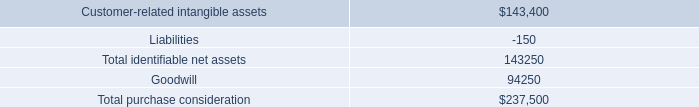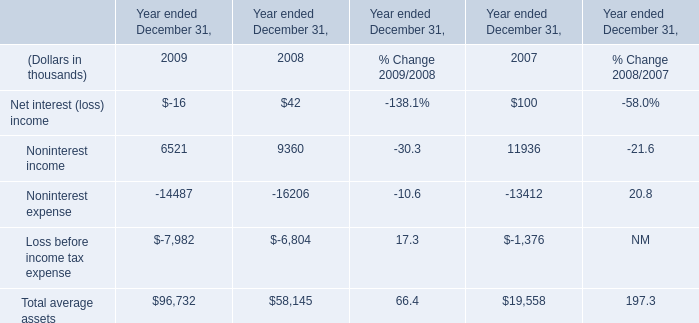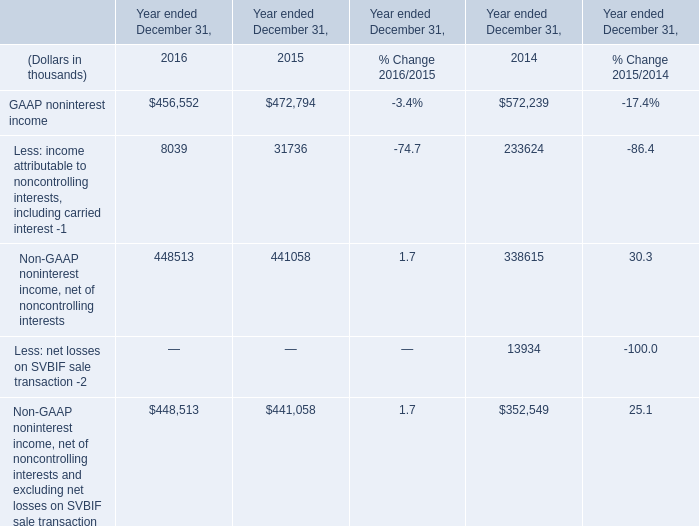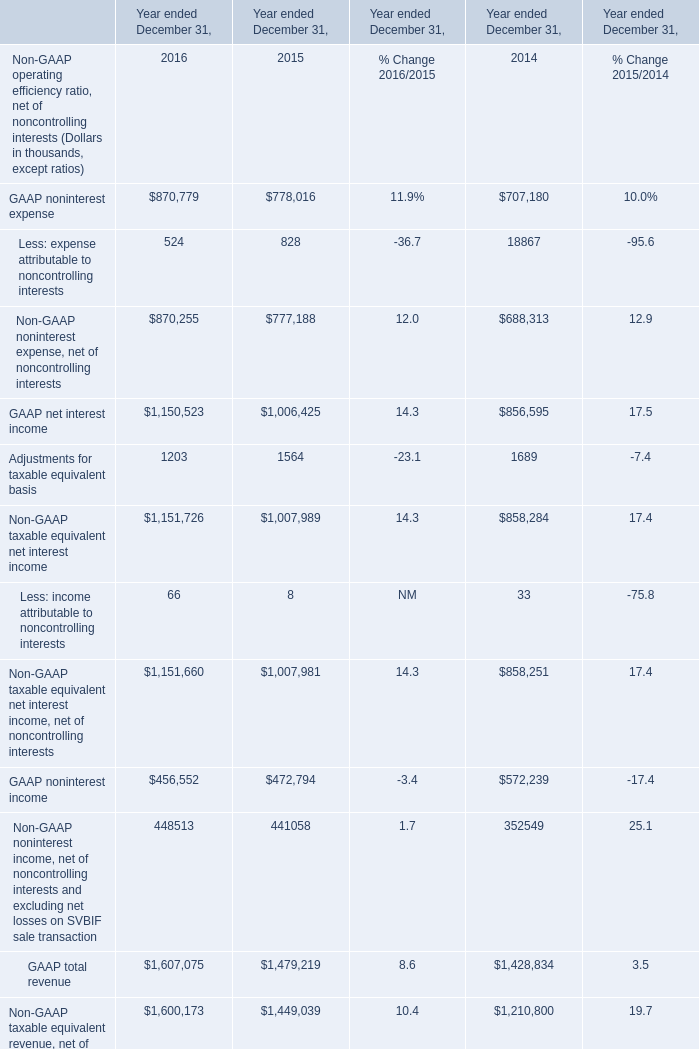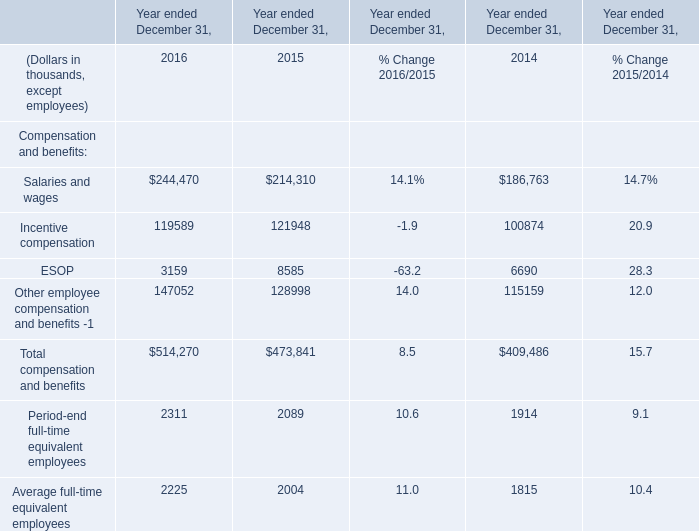What's the increasing rate of Salaries and wages in 2016? 
Computations: ((244470 - 214310) / 214310)
Answer: 0.14073. 